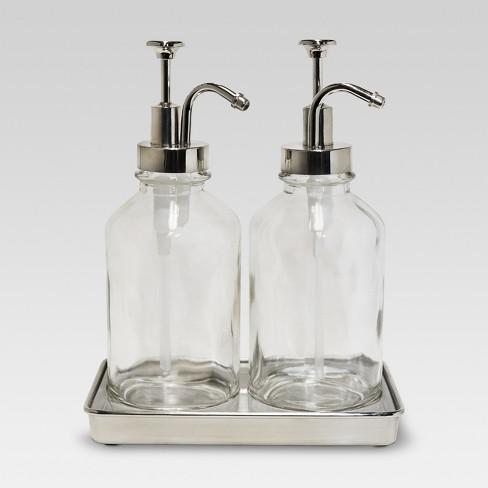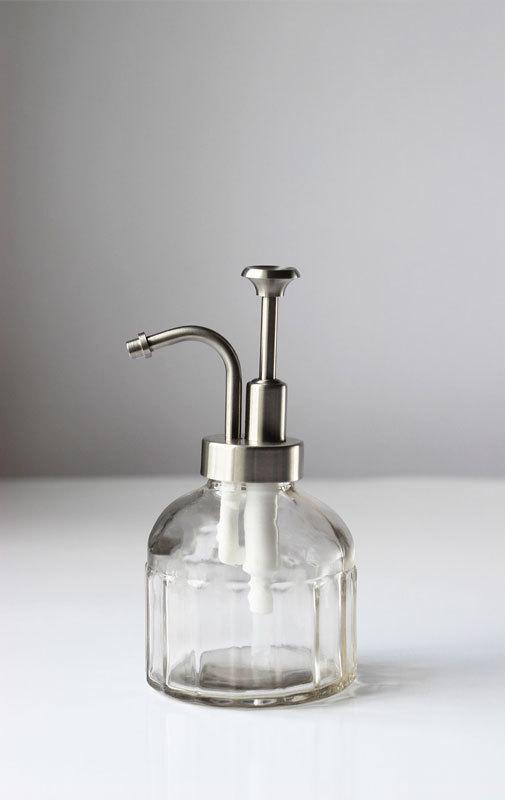The first image is the image on the left, the second image is the image on the right. For the images shown, is this caption "The left image features a caddy that holds two dispenser bottles side-by-side, and their pump nozzles face right." true? Answer yes or no. Yes. The first image is the image on the left, the second image is the image on the right. Considering the images on both sides, is "There are exactly two clear dispensers, one in each image." valid? Answer yes or no. No. 